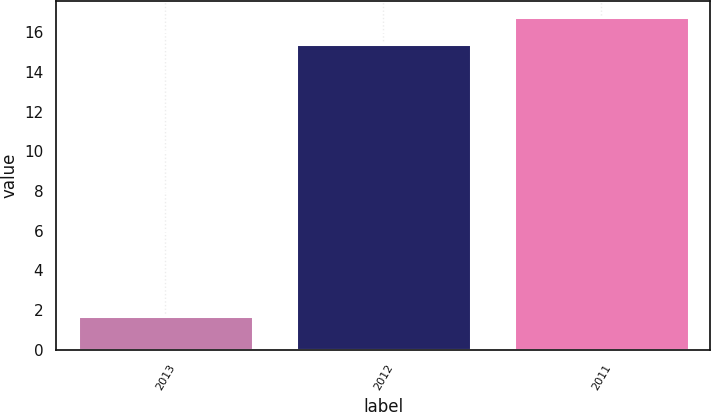Convert chart. <chart><loc_0><loc_0><loc_500><loc_500><bar_chart><fcel>2013<fcel>2012<fcel>2011<nl><fcel>1.7<fcel>15.4<fcel>16.77<nl></chart> 